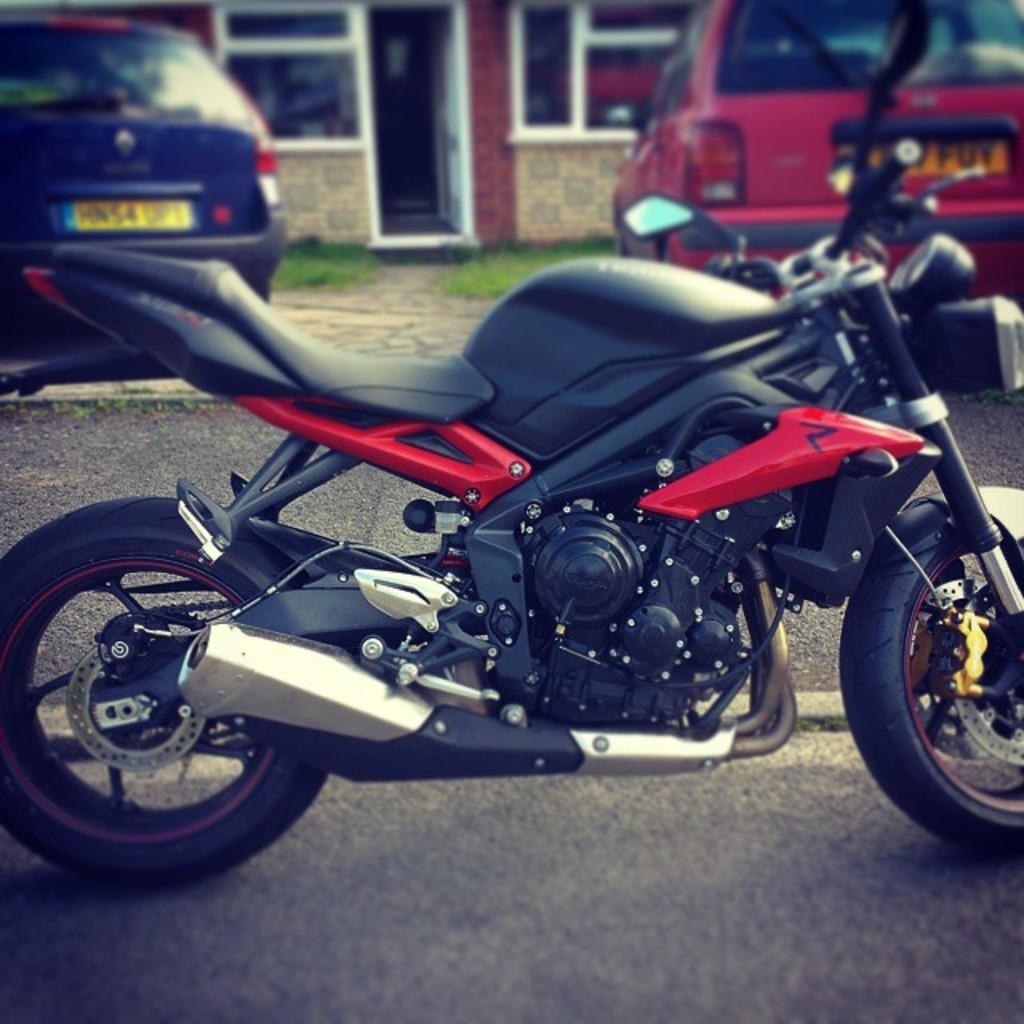What is the main subject of the image? There is a bike on the road in the image. What vehicles are present behind the bike? There is a blue car behind the bike, and a red car behind the blue car. What type of vegetation can be seen in the image? There is grass on the land in the image. What type of structure is visible in the background? There is a house visible in the background of the image. How many oranges are hanging from the bike in the image? There are no oranges present in the image. What type of stick is being used by the bike to balance in the image? There is no stick being used by the bike in the image; it is simply on the road. 